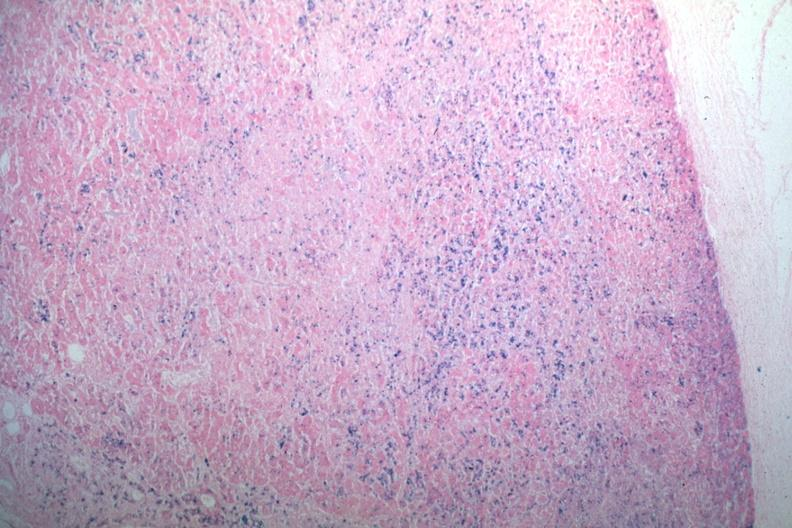s endocrine present?
Answer the question using a single word or phrase. Yes 